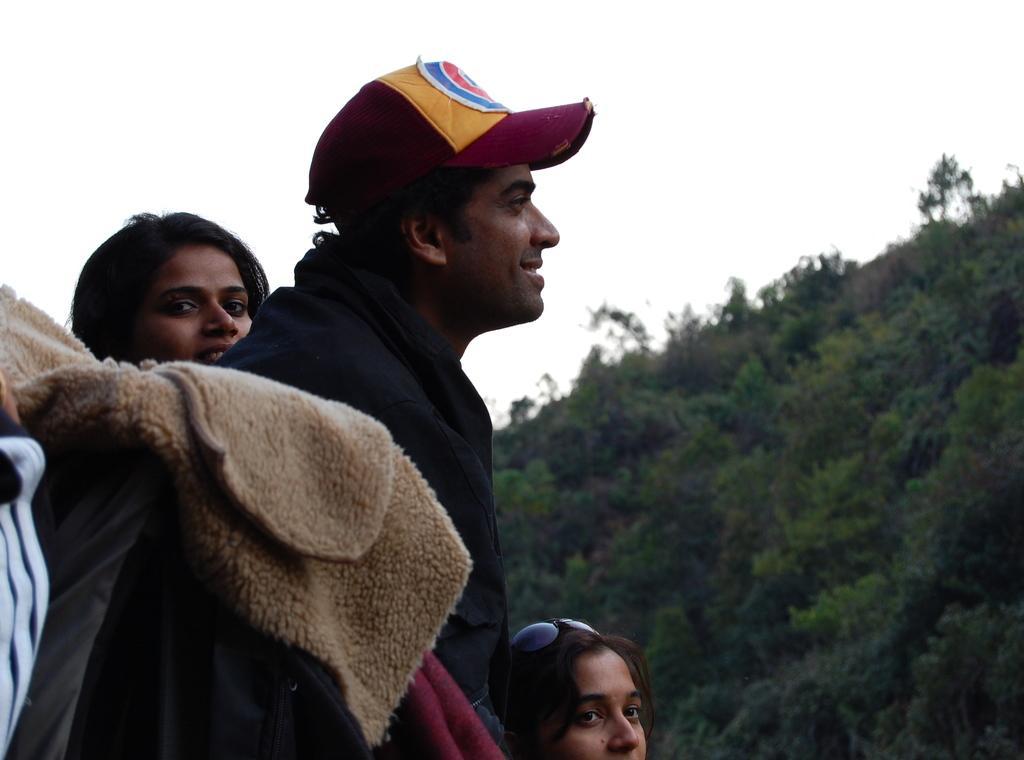Can you describe this image briefly? On the left side of the image, we can see three persons. We can see a man is wearing a cap and smiling. On the right side of the image, we can see so many trees. In the background, there is the sky. 